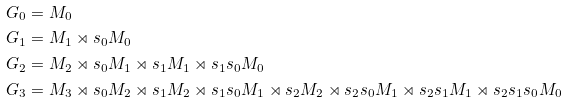Convert formula to latex. <formula><loc_0><loc_0><loc_500><loc_500>G _ { 0 } & = M _ { 0 } \\ G _ { 1 } & = M _ { 1 } \rtimes s _ { 0 } M _ { 0 } \\ G _ { 2 } & = M _ { 2 } \rtimes s _ { 0 } M _ { 1 } \rtimes s _ { 1 } M _ { 1 } \rtimes s _ { 1 } s _ { 0 } M _ { 0 } \\ G _ { 3 } & = M _ { 3 } \rtimes s _ { 0 } M _ { 2 } \rtimes s _ { 1 } M _ { 2 } \rtimes s _ { 1 } s _ { 0 } M _ { 1 } \rtimes s _ { 2 } M _ { 2 } \rtimes s _ { 2 } s _ { 0 } M _ { 1 } \rtimes s _ { 2 } s _ { 1 } M _ { 1 } \rtimes s _ { 2 } s _ { 1 } s _ { 0 } M _ { 0 }</formula> 